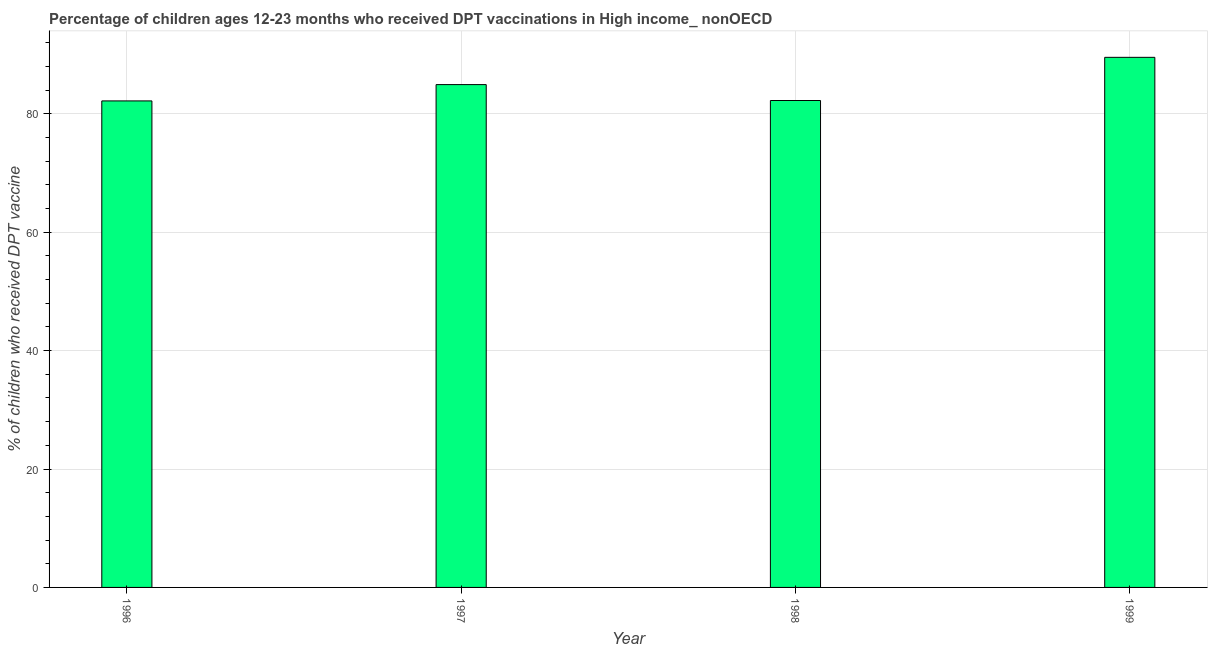What is the title of the graph?
Offer a terse response. Percentage of children ages 12-23 months who received DPT vaccinations in High income_ nonOECD. What is the label or title of the Y-axis?
Provide a succinct answer. % of children who received DPT vaccine. What is the percentage of children who received dpt vaccine in 1996?
Keep it short and to the point. 82.18. Across all years, what is the maximum percentage of children who received dpt vaccine?
Make the answer very short. 89.54. Across all years, what is the minimum percentage of children who received dpt vaccine?
Provide a short and direct response. 82.18. In which year was the percentage of children who received dpt vaccine maximum?
Offer a very short reply. 1999. What is the sum of the percentage of children who received dpt vaccine?
Keep it short and to the point. 338.9. What is the difference between the percentage of children who received dpt vaccine in 1997 and 1999?
Your response must be concise. -4.61. What is the average percentage of children who received dpt vaccine per year?
Keep it short and to the point. 84.73. What is the median percentage of children who received dpt vaccine?
Keep it short and to the point. 83.59. In how many years, is the percentage of children who received dpt vaccine greater than 52 %?
Your answer should be compact. 4. What is the ratio of the percentage of children who received dpt vaccine in 1996 to that in 1999?
Provide a short and direct response. 0.92. What is the difference between the highest and the second highest percentage of children who received dpt vaccine?
Your response must be concise. 4.61. What is the difference between the highest and the lowest percentage of children who received dpt vaccine?
Offer a very short reply. 7.36. How many bars are there?
Give a very brief answer. 4. What is the % of children who received DPT vaccine in 1996?
Provide a succinct answer. 82.18. What is the % of children who received DPT vaccine of 1997?
Provide a short and direct response. 84.94. What is the % of children who received DPT vaccine in 1998?
Provide a succinct answer. 82.25. What is the % of children who received DPT vaccine of 1999?
Offer a terse response. 89.54. What is the difference between the % of children who received DPT vaccine in 1996 and 1997?
Give a very brief answer. -2.76. What is the difference between the % of children who received DPT vaccine in 1996 and 1998?
Your answer should be very brief. -0.07. What is the difference between the % of children who received DPT vaccine in 1996 and 1999?
Your answer should be compact. -7.36. What is the difference between the % of children who received DPT vaccine in 1997 and 1998?
Ensure brevity in your answer.  2.69. What is the difference between the % of children who received DPT vaccine in 1997 and 1999?
Your answer should be very brief. -4.61. What is the difference between the % of children who received DPT vaccine in 1998 and 1999?
Make the answer very short. -7.29. What is the ratio of the % of children who received DPT vaccine in 1996 to that in 1997?
Provide a short and direct response. 0.97. What is the ratio of the % of children who received DPT vaccine in 1996 to that in 1999?
Your response must be concise. 0.92. What is the ratio of the % of children who received DPT vaccine in 1997 to that in 1998?
Offer a very short reply. 1.03. What is the ratio of the % of children who received DPT vaccine in 1997 to that in 1999?
Make the answer very short. 0.95. What is the ratio of the % of children who received DPT vaccine in 1998 to that in 1999?
Offer a terse response. 0.92. 